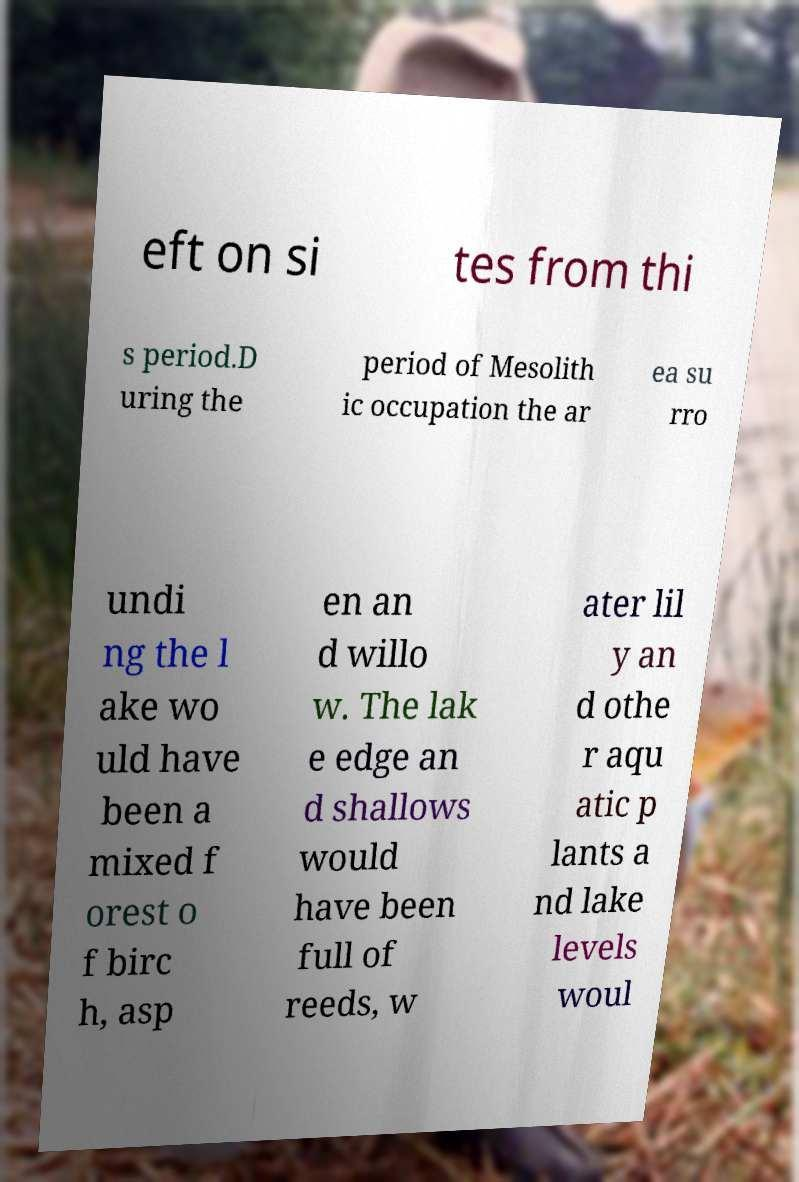There's text embedded in this image that I need extracted. Can you transcribe it verbatim? eft on si tes from thi s period.D uring the period of Mesolith ic occupation the ar ea su rro undi ng the l ake wo uld have been a mixed f orest o f birc h, asp en an d willo w. The lak e edge an d shallows would have been full of reeds, w ater lil y an d othe r aqu atic p lants a nd lake levels woul 